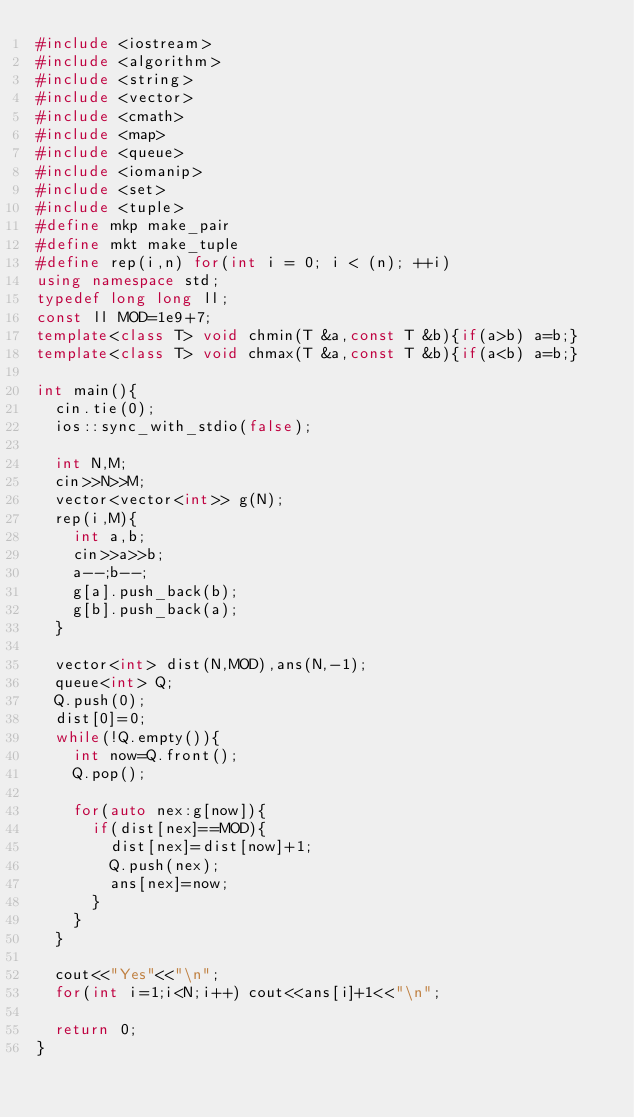<code> <loc_0><loc_0><loc_500><loc_500><_C++_>#include <iostream>
#include <algorithm>
#include <string>
#include <vector>
#include <cmath>
#include <map>
#include <queue>
#include <iomanip>
#include <set>
#include <tuple>
#define mkp make_pair
#define mkt make_tuple
#define rep(i,n) for(int i = 0; i < (n); ++i)
using namespace std;
typedef long long ll;
const ll MOD=1e9+7;
template<class T> void chmin(T &a,const T &b){if(a>b) a=b;}
template<class T> void chmax(T &a,const T &b){if(a<b) a=b;}

int main(){
  cin.tie(0);
  ios::sync_with_stdio(false);

  int N,M;
  cin>>N>>M;
  vector<vector<int>> g(N);
  rep(i,M){
    int a,b;
    cin>>a>>b;
    a--;b--;
    g[a].push_back(b);
    g[b].push_back(a);
  }

  vector<int> dist(N,MOD),ans(N,-1);
  queue<int> Q;
  Q.push(0);
  dist[0]=0;
  while(!Q.empty()){
    int now=Q.front();
    Q.pop();

    for(auto nex:g[now]){
      if(dist[nex]==MOD){
        dist[nex]=dist[now]+1;
        Q.push(nex);
        ans[nex]=now;
      }
    }
  }

  cout<<"Yes"<<"\n";
  for(int i=1;i<N;i++) cout<<ans[i]+1<<"\n";

  return 0;
}
</code> 